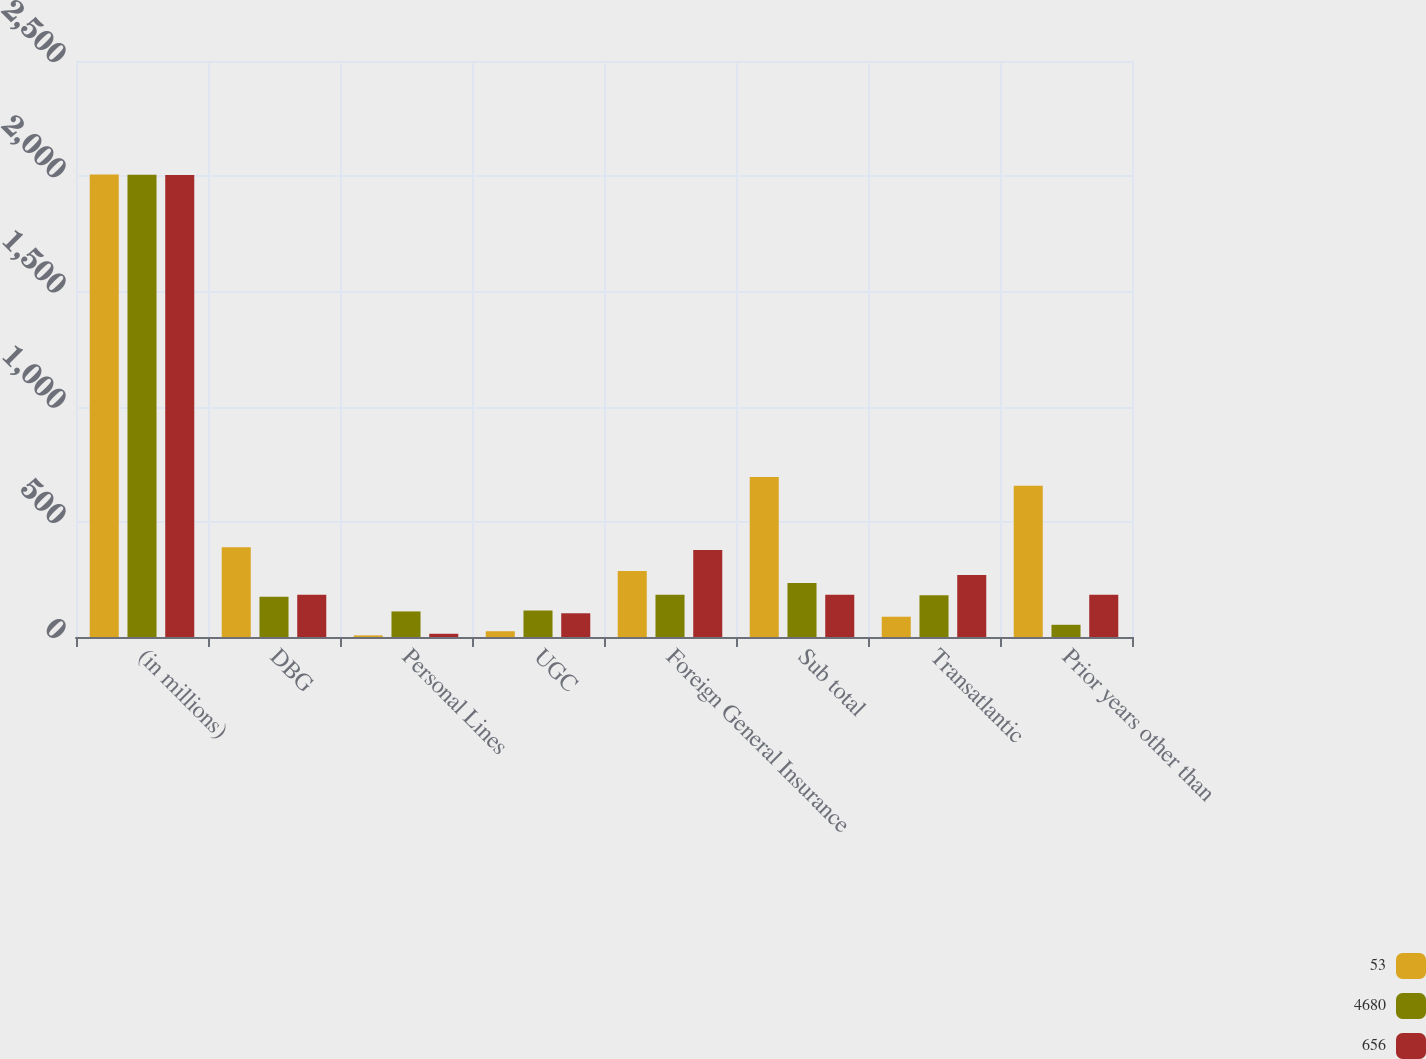Convert chart. <chart><loc_0><loc_0><loc_500><loc_500><stacked_bar_chart><ecel><fcel>(in millions)<fcel>DBG<fcel>Personal Lines<fcel>UGC<fcel>Foreign General Insurance<fcel>Sub total<fcel>Transatlantic<fcel>Prior years other than<nl><fcel>53<fcel>2007<fcel>390<fcel>7<fcel>25<fcel>286<fcel>694<fcel>88<fcel>656<nl><fcel>4680<fcel>2006<fcel>175<fcel>111<fcel>115<fcel>183<fcel>234<fcel>181<fcel>53<nl><fcel>656<fcel>2005<fcel>183<fcel>14<fcel>103<fcel>378<fcel>183<fcel>269<fcel>183<nl></chart> 